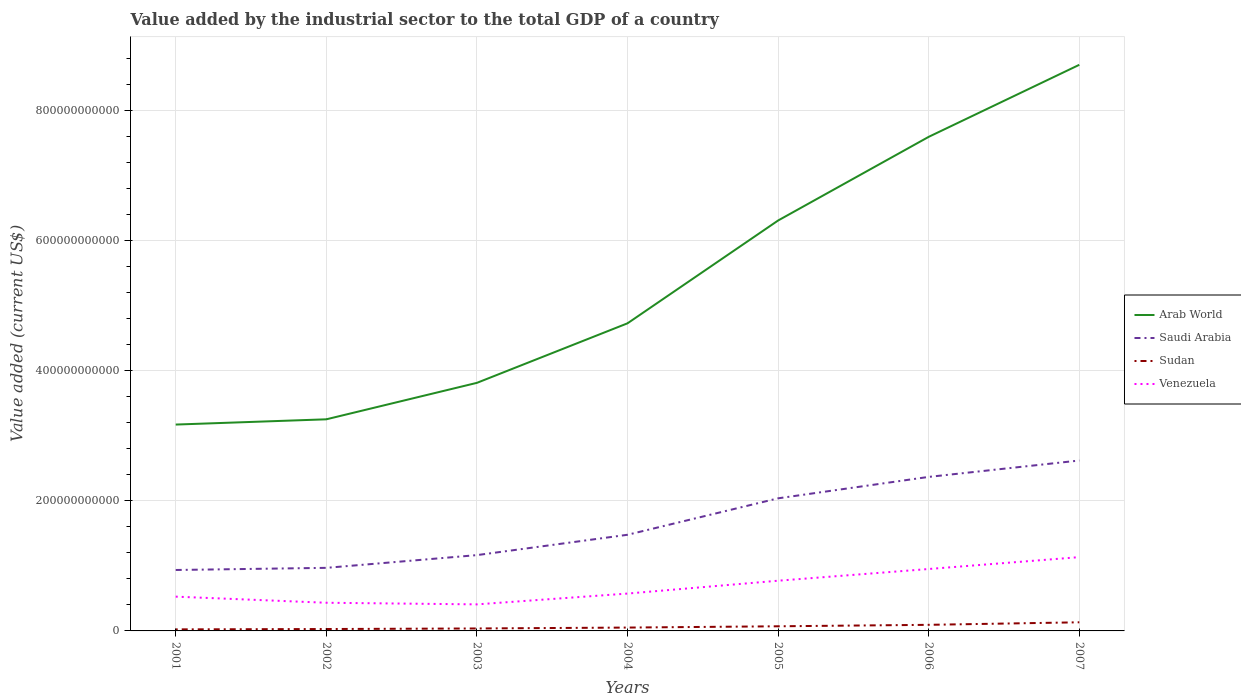How many different coloured lines are there?
Your answer should be compact. 4. Does the line corresponding to Saudi Arabia intersect with the line corresponding to Arab World?
Give a very brief answer. No. Across all years, what is the maximum value added by the industrial sector to the total GDP in Saudi Arabia?
Offer a very short reply. 9.38e+1. What is the total value added by the industrial sector to the total GDP in Sudan in the graph?
Offer a very short reply. -4.22e+09. What is the difference between the highest and the second highest value added by the industrial sector to the total GDP in Saudi Arabia?
Make the answer very short. 1.68e+11. Is the value added by the industrial sector to the total GDP in Saudi Arabia strictly greater than the value added by the industrial sector to the total GDP in Arab World over the years?
Your answer should be very brief. Yes. What is the difference between two consecutive major ticks on the Y-axis?
Make the answer very short. 2.00e+11. Are the values on the major ticks of Y-axis written in scientific E-notation?
Make the answer very short. No. Does the graph contain grids?
Offer a very short reply. Yes. Where does the legend appear in the graph?
Your answer should be very brief. Center right. How many legend labels are there?
Give a very brief answer. 4. What is the title of the graph?
Offer a very short reply. Value added by the industrial sector to the total GDP of a country. Does "Sweden" appear as one of the legend labels in the graph?
Offer a very short reply. No. What is the label or title of the Y-axis?
Your response must be concise. Value added (current US$). What is the Value added (current US$) of Arab World in 2001?
Your response must be concise. 3.18e+11. What is the Value added (current US$) in Saudi Arabia in 2001?
Make the answer very short. 9.38e+1. What is the Value added (current US$) in Sudan in 2001?
Offer a very short reply. 2.37e+09. What is the Value added (current US$) in Venezuela in 2001?
Offer a very short reply. 5.27e+1. What is the Value added (current US$) in Arab World in 2002?
Your answer should be compact. 3.26e+11. What is the Value added (current US$) in Saudi Arabia in 2002?
Keep it short and to the point. 9.71e+1. What is the Value added (current US$) of Sudan in 2002?
Offer a very short reply. 2.92e+09. What is the Value added (current US$) of Venezuela in 2002?
Your answer should be very brief. 4.33e+1. What is the Value added (current US$) in Arab World in 2003?
Make the answer very short. 3.82e+11. What is the Value added (current US$) of Saudi Arabia in 2003?
Make the answer very short. 1.17e+11. What is the Value added (current US$) in Sudan in 2003?
Your answer should be very brief. 3.78e+09. What is the Value added (current US$) of Venezuela in 2003?
Your answer should be compact. 4.08e+1. What is the Value added (current US$) of Arab World in 2004?
Ensure brevity in your answer.  4.73e+11. What is the Value added (current US$) of Saudi Arabia in 2004?
Your answer should be very brief. 1.48e+11. What is the Value added (current US$) in Sudan in 2004?
Give a very brief answer. 5.16e+09. What is the Value added (current US$) of Venezuela in 2004?
Offer a very short reply. 5.75e+1. What is the Value added (current US$) of Arab World in 2005?
Your response must be concise. 6.31e+11. What is the Value added (current US$) of Saudi Arabia in 2005?
Provide a short and direct response. 2.04e+11. What is the Value added (current US$) of Sudan in 2005?
Your answer should be very brief. 7.13e+09. What is the Value added (current US$) in Venezuela in 2005?
Your answer should be compact. 7.73e+1. What is the Value added (current US$) of Arab World in 2006?
Offer a very short reply. 7.60e+11. What is the Value added (current US$) in Saudi Arabia in 2006?
Provide a succinct answer. 2.37e+11. What is the Value added (current US$) of Sudan in 2006?
Provide a short and direct response. 9.38e+09. What is the Value added (current US$) of Venezuela in 2006?
Ensure brevity in your answer.  9.53e+1. What is the Value added (current US$) of Arab World in 2007?
Make the answer very short. 8.71e+11. What is the Value added (current US$) of Saudi Arabia in 2007?
Provide a short and direct response. 2.62e+11. What is the Value added (current US$) in Sudan in 2007?
Keep it short and to the point. 1.33e+1. What is the Value added (current US$) in Venezuela in 2007?
Keep it short and to the point. 1.14e+11. Across all years, what is the maximum Value added (current US$) in Arab World?
Offer a terse response. 8.71e+11. Across all years, what is the maximum Value added (current US$) of Saudi Arabia?
Your response must be concise. 2.62e+11. Across all years, what is the maximum Value added (current US$) in Sudan?
Your answer should be very brief. 1.33e+1. Across all years, what is the maximum Value added (current US$) of Venezuela?
Ensure brevity in your answer.  1.14e+11. Across all years, what is the minimum Value added (current US$) of Arab World?
Offer a terse response. 3.18e+11. Across all years, what is the minimum Value added (current US$) in Saudi Arabia?
Your answer should be compact. 9.38e+1. Across all years, what is the minimum Value added (current US$) in Sudan?
Your response must be concise. 2.37e+09. Across all years, what is the minimum Value added (current US$) of Venezuela?
Keep it short and to the point. 4.08e+1. What is the total Value added (current US$) of Arab World in the graph?
Your response must be concise. 3.76e+12. What is the total Value added (current US$) in Saudi Arabia in the graph?
Provide a short and direct response. 1.16e+12. What is the total Value added (current US$) of Sudan in the graph?
Provide a succinct answer. 4.40e+1. What is the total Value added (current US$) in Venezuela in the graph?
Your response must be concise. 4.80e+11. What is the difference between the Value added (current US$) in Arab World in 2001 and that in 2002?
Provide a succinct answer. -8.06e+09. What is the difference between the Value added (current US$) in Saudi Arabia in 2001 and that in 2002?
Provide a short and direct response. -3.30e+09. What is the difference between the Value added (current US$) of Sudan in 2001 and that in 2002?
Your answer should be very brief. -5.44e+08. What is the difference between the Value added (current US$) in Venezuela in 2001 and that in 2002?
Your response must be concise. 9.40e+09. What is the difference between the Value added (current US$) in Arab World in 2001 and that in 2003?
Make the answer very short. -6.42e+1. What is the difference between the Value added (current US$) of Saudi Arabia in 2001 and that in 2003?
Provide a succinct answer. -2.29e+1. What is the difference between the Value added (current US$) in Sudan in 2001 and that in 2003?
Provide a succinct answer. -1.40e+09. What is the difference between the Value added (current US$) of Venezuela in 2001 and that in 2003?
Your response must be concise. 1.19e+1. What is the difference between the Value added (current US$) of Arab World in 2001 and that in 2004?
Provide a succinct answer. -1.56e+11. What is the difference between the Value added (current US$) in Saudi Arabia in 2001 and that in 2004?
Your response must be concise. -5.42e+1. What is the difference between the Value added (current US$) of Sudan in 2001 and that in 2004?
Offer a very short reply. -2.79e+09. What is the difference between the Value added (current US$) of Venezuela in 2001 and that in 2004?
Keep it short and to the point. -4.74e+09. What is the difference between the Value added (current US$) in Arab World in 2001 and that in 2005?
Your answer should be compact. -3.14e+11. What is the difference between the Value added (current US$) of Saudi Arabia in 2001 and that in 2005?
Keep it short and to the point. -1.10e+11. What is the difference between the Value added (current US$) in Sudan in 2001 and that in 2005?
Offer a very short reply. -4.75e+09. What is the difference between the Value added (current US$) in Venezuela in 2001 and that in 2005?
Your response must be concise. -2.45e+1. What is the difference between the Value added (current US$) in Arab World in 2001 and that in 2006?
Your response must be concise. -4.43e+11. What is the difference between the Value added (current US$) of Saudi Arabia in 2001 and that in 2006?
Ensure brevity in your answer.  -1.43e+11. What is the difference between the Value added (current US$) of Sudan in 2001 and that in 2006?
Your response must be concise. -7.01e+09. What is the difference between the Value added (current US$) of Venezuela in 2001 and that in 2006?
Your answer should be very brief. -4.25e+1. What is the difference between the Value added (current US$) in Arab World in 2001 and that in 2007?
Provide a succinct answer. -5.54e+11. What is the difference between the Value added (current US$) of Saudi Arabia in 2001 and that in 2007?
Make the answer very short. -1.68e+11. What is the difference between the Value added (current US$) of Sudan in 2001 and that in 2007?
Provide a short and direct response. -1.09e+1. What is the difference between the Value added (current US$) of Venezuela in 2001 and that in 2007?
Provide a succinct answer. -6.08e+1. What is the difference between the Value added (current US$) in Arab World in 2002 and that in 2003?
Ensure brevity in your answer.  -5.61e+1. What is the difference between the Value added (current US$) in Saudi Arabia in 2002 and that in 2003?
Your response must be concise. -1.96e+1. What is the difference between the Value added (current US$) in Sudan in 2002 and that in 2003?
Your answer should be very brief. -8.58e+08. What is the difference between the Value added (current US$) of Venezuela in 2002 and that in 2003?
Provide a succinct answer. 2.50e+09. What is the difference between the Value added (current US$) in Arab World in 2002 and that in 2004?
Provide a short and direct response. -1.48e+11. What is the difference between the Value added (current US$) of Saudi Arabia in 2002 and that in 2004?
Your answer should be compact. -5.09e+1. What is the difference between the Value added (current US$) of Sudan in 2002 and that in 2004?
Keep it short and to the point. -2.24e+09. What is the difference between the Value added (current US$) in Venezuela in 2002 and that in 2004?
Provide a succinct answer. -1.41e+1. What is the difference between the Value added (current US$) in Arab World in 2002 and that in 2005?
Ensure brevity in your answer.  -3.06e+11. What is the difference between the Value added (current US$) in Saudi Arabia in 2002 and that in 2005?
Ensure brevity in your answer.  -1.07e+11. What is the difference between the Value added (current US$) of Sudan in 2002 and that in 2005?
Give a very brief answer. -4.21e+09. What is the difference between the Value added (current US$) in Venezuela in 2002 and that in 2005?
Make the answer very short. -3.39e+1. What is the difference between the Value added (current US$) of Arab World in 2002 and that in 2006?
Your response must be concise. -4.35e+11. What is the difference between the Value added (current US$) of Saudi Arabia in 2002 and that in 2006?
Ensure brevity in your answer.  -1.40e+11. What is the difference between the Value added (current US$) of Sudan in 2002 and that in 2006?
Ensure brevity in your answer.  -6.46e+09. What is the difference between the Value added (current US$) of Venezuela in 2002 and that in 2006?
Keep it short and to the point. -5.19e+1. What is the difference between the Value added (current US$) of Arab World in 2002 and that in 2007?
Your response must be concise. -5.45e+11. What is the difference between the Value added (current US$) in Saudi Arabia in 2002 and that in 2007?
Offer a terse response. -1.65e+11. What is the difference between the Value added (current US$) of Sudan in 2002 and that in 2007?
Provide a short and direct response. -1.03e+1. What is the difference between the Value added (current US$) in Venezuela in 2002 and that in 2007?
Your answer should be compact. -7.02e+1. What is the difference between the Value added (current US$) of Arab World in 2003 and that in 2004?
Offer a very short reply. -9.16e+1. What is the difference between the Value added (current US$) of Saudi Arabia in 2003 and that in 2004?
Make the answer very short. -3.13e+1. What is the difference between the Value added (current US$) of Sudan in 2003 and that in 2004?
Your response must be concise. -1.38e+09. What is the difference between the Value added (current US$) of Venezuela in 2003 and that in 2004?
Your answer should be compact. -1.66e+1. What is the difference between the Value added (current US$) of Arab World in 2003 and that in 2005?
Your answer should be very brief. -2.50e+11. What is the difference between the Value added (current US$) in Saudi Arabia in 2003 and that in 2005?
Your response must be concise. -8.74e+1. What is the difference between the Value added (current US$) of Sudan in 2003 and that in 2005?
Offer a very short reply. -3.35e+09. What is the difference between the Value added (current US$) of Venezuela in 2003 and that in 2005?
Ensure brevity in your answer.  -3.64e+1. What is the difference between the Value added (current US$) of Arab World in 2003 and that in 2006?
Offer a terse response. -3.79e+11. What is the difference between the Value added (current US$) of Saudi Arabia in 2003 and that in 2006?
Ensure brevity in your answer.  -1.20e+11. What is the difference between the Value added (current US$) in Sudan in 2003 and that in 2006?
Make the answer very short. -5.61e+09. What is the difference between the Value added (current US$) in Venezuela in 2003 and that in 2006?
Your answer should be compact. -5.44e+1. What is the difference between the Value added (current US$) of Arab World in 2003 and that in 2007?
Your answer should be very brief. -4.89e+11. What is the difference between the Value added (current US$) in Saudi Arabia in 2003 and that in 2007?
Your answer should be compact. -1.46e+11. What is the difference between the Value added (current US$) in Sudan in 2003 and that in 2007?
Keep it short and to the point. -9.49e+09. What is the difference between the Value added (current US$) in Venezuela in 2003 and that in 2007?
Provide a short and direct response. -7.27e+1. What is the difference between the Value added (current US$) of Arab World in 2004 and that in 2005?
Your answer should be compact. -1.58e+11. What is the difference between the Value added (current US$) in Saudi Arabia in 2004 and that in 2005?
Offer a very short reply. -5.61e+1. What is the difference between the Value added (current US$) in Sudan in 2004 and that in 2005?
Provide a short and direct response. -1.97e+09. What is the difference between the Value added (current US$) of Venezuela in 2004 and that in 2005?
Your answer should be very brief. -1.98e+1. What is the difference between the Value added (current US$) in Arab World in 2004 and that in 2006?
Make the answer very short. -2.87e+11. What is the difference between the Value added (current US$) in Saudi Arabia in 2004 and that in 2006?
Your answer should be very brief. -8.90e+1. What is the difference between the Value added (current US$) of Sudan in 2004 and that in 2006?
Your answer should be very brief. -4.22e+09. What is the difference between the Value added (current US$) of Venezuela in 2004 and that in 2006?
Keep it short and to the point. -3.78e+1. What is the difference between the Value added (current US$) in Arab World in 2004 and that in 2007?
Offer a very short reply. -3.98e+11. What is the difference between the Value added (current US$) in Saudi Arabia in 2004 and that in 2007?
Make the answer very short. -1.14e+11. What is the difference between the Value added (current US$) of Sudan in 2004 and that in 2007?
Your answer should be compact. -8.10e+09. What is the difference between the Value added (current US$) in Venezuela in 2004 and that in 2007?
Provide a short and direct response. -5.61e+1. What is the difference between the Value added (current US$) in Arab World in 2005 and that in 2006?
Give a very brief answer. -1.29e+11. What is the difference between the Value added (current US$) of Saudi Arabia in 2005 and that in 2006?
Offer a terse response. -3.30e+1. What is the difference between the Value added (current US$) of Sudan in 2005 and that in 2006?
Your answer should be very brief. -2.25e+09. What is the difference between the Value added (current US$) of Venezuela in 2005 and that in 2006?
Offer a terse response. -1.80e+1. What is the difference between the Value added (current US$) of Arab World in 2005 and that in 2007?
Your response must be concise. -2.40e+11. What is the difference between the Value added (current US$) of Saudi Arabia in 2005 and that in 2007?
Ensure brevity in your answer.  -5.82e+1. What is the difference between the Value added (current US$) in Sudan in 2005 and that in 2007?
Give a very brief answer. -6.13e+09. What is the difference between the Value added (current US$) of Venezuela in 2005 and that in 2007?
Your answer should be very brief. -3.63e+1. What is the difference between the Value added (current US$) in Arab World in 2006 and that in 2007?
Offer a terse response. -1.11e+11. What is the difference between the Value added (current US$) in Saudi Arabia in 2006 and that in 2007?
Your answer should be compact. -2.52e+1. What is the difference between the Value added (current US$) in Sudan in 2006 and that in 2007?
Offer a very short reply. -3.88e+09. What is the difference between the Value added (current US$) of Venezuela in 2006 and that in 2007?
Provide a succinct answer. -1.83e+1. What is the difference between the Value added (current US$) of Arab World in 2001 and the Value added (current US$) of Saudi Arabia in 2002?
Give a very brief answer. 2.20e+11. What is the difference between the Value added (current US$) in Arab World in 2001 and the Value added (current US$) in Sudan in 2002?
Keep it short and to the point. 3.15e+11. What is the difference between the Value added (current US$) in Arab World in 2001 and the Value added (current US$) in Venezuela in 2002?
Ensure brevity in your answer.  2.74e+11. What is the difference between the Value added (current US$) in Saudi Arabia in 2001 and the Value added (current US$) in Sudan in 2002?
Your response must be concise. 9.08e+1. What is the difference between the Value added (current US$) in Saudi Arabia in 2001 and the Value added (current US$) in Venezuela in 2002?
Keep it short and to the point. 5.04e+1. What is the difference between the Value added (current US$) in Sudan in 2001 and the Value added (current US$) in Venezuela in 2002?
Your answer should be compact. -4.10e+1. What is the difference between the Value added (current US$) in Arab World in 2001 and the Value added (current US$) in Saudi Arabia in 2003?
Make the answer very short. 2.01e+11. What is the difference between the Value added (current US$) of Arab World in 2001 and the Value added (current US$) of Sudan in 2003?
Your answer should be very brief. 3.14e+11. What is the difference between the Value added (current US$) in Arab World in 2001 and the Value added (current US$) in Venezuela in 2003?
Provide a succinct answer. 2.77e+11. What is the difference between the Value added (current US$) in Saudi Arabia in 2001 and the Value added (current US$) in Sudan in 2003?
Provide a succinct answer. 9.00e+1. What is the difference between the Value added (current US$) in Saudi Arabia in 2001 and the Value added (current US$) in Venezuela in 2003?
Your response must be concise. 5.29e+1. What is the difference between the Value added (current US$) of Sudan in 2001 and the Value added (current US$) of Venezuela in 2003?
Ensure brevity in your answer.  -3.85e+1. What is the difference between the Value added (current US$) in Arab World in 2001 and the Value added (current US$) in Saudi Arabia in 2004?
Your answer should be very brief. 1.70e+11. What is the difference between the Value added (current US$) of Arab World in 2001 and the Value added (current US$) of Sudan in 2004?
Provide a short and direct response. 3.12e+11. What is the difference between the Value added (current US$) of Arab World in 2001 and the Value added (current US$) of Venezuela in 2004?
Offer a very short reply. 2.60e+11. What is the difference between the Value added (current US$) of Saudi Arabia in 2001 and the Value added (current US$) of Sudan in 2004?
Your answer should be compact. 8.86e+1. What is the difference between the Value added (current US$) in Saudi Arabia in 2001 and the Value added (current US$) in Venezuela in 2004?
Keep it short and to the point. 3.63e+1. What is the difference between the Value added (current US$) of Sudan in 2001 and the Value added (current US$) of Venezuela in 2004?
Your answer should be compact. -5.51e+1. What is the difference between the Value added (current US$) of Arab World in 2001 and the Value added (current US$) of Saudi Arabia in 2005?
Provide a short and direct response. 1.14e+11. What is the difference between the Value added (current US$) in Arab World in 2001 and the Value added (current US$) in Sudan in 2005?
Provide a succinct answer. 3.10e+11. What is the difference between the Value added (current US$) in Arab World in 2001 and the Value added (current US$) in Venezuela in 2005?
Give a very brief answer. 2.40e+11. What is the difference between the Value added (current US$) in Saudi Arabia in 2001 and the Value added (current US$) in Sudan in 2005?
Your answer should be very brief. 8.66e+1. What is the difference between the Value added (current US$) of Saudi Arabia in 2001 and the Value added (current US$) of Venezuela in 2005?
Provide a short and direct response. 1.65e+1. What is the difference between the Value added (current US$) in Sudan in 2001 and the Value added (current US$) in Venezuela in 2005?
Keep it short and to the point. -7.49e+1. What is the difference between the Value added (current US$) of Arab World in 2001 and the Value added (current US$) of Saudi Arabia in 2006?
Ensure brevity in your answer.  8.05e+1. What is the difference between the Value added (current US$) in Arab World in 2001 and the Value added (current US$) in Sudan in 2006?
Ensure brevity in your answer.  3.08e+11. What is the difference between the Value added (current US$) of Arab World in 2001 and the Value added (current US$) of Venezuela in 2006?
Provide a short and direct response. 2.22e+11. What is the difference between the Value added (current US$) in Saudi Arabia in 2001 and the Value added (current US$) in Sudan in 2006?
Provide a short and direct response. 8.44e+1. What is the difference between the Value added (current US$) of Saudi Arabia in 2001 and the Value added (current US$) of Venezuela in 2006?
Provide a short and direct response. -1.52e+09. What is the difference between the Value added (current US$) in Sudan in 2001 and the Value added (current US$) in Venezuela in 2006?
Give a very brief answer. -9.29e+1. What is the difference between the Value added (current US$) of Arab World in 2001 and the Value added (current US$) of Saudi Arabia in 2007?
Your answer should be compact. 5.53e+1. What is the difference between the Value added (current US$) of Arab World in 2001 and the Value added (current US$) of Sudan in 2007?
Provide a succinct answer. 3.04e+11. What is the difference between the Value added (current US$) in Arab World in 2001 and the Value added (current US$) in Venezuela in 2007?
Provide a succinct answer. 2.04e+11. What is the difference between the Value added (current US$) in Saudi Arabia in 2001 and the Value added (current US$) in Sudan in 2007?
Keep it short and to the point. 8.05e+1. What is the difference between the Value added (current US$) of Saudi Arabia in 2001 and the Value added (current US$) of Venezuela in 2007?
Offer a terse response. -1.98e+1. What is the difference between the Value added (current US$) of Sudan in 2001 and the Value added (current US$) of Venezuela in 2007?
Your response must be concise. -1.11e+11. What is the difference between the Value added (current US$) of Arab World in 2002 and the Value added (current US$) of Saudi Arabia in 2003?
Your answer should be very brief. 2.09e+11. What is the difference between the Value added (current US$) in Arab World in 2002 and the Value added (current US$) in Sudan in 2003?
Your response must be concise. 3.22e+11. What is the difference between the Value added (current US$) in Arab World in 2002 and the Value added (current US$) in Venezuela in 2003?
Offer a terse response. 2.85e+11. What is the difference between the Value added (current US$) of Saudi Arabia in 2002 and the Value added (current US$) of Sudan in 2003?
Keep it short and to the point. 9.33e+1. What is the difference between the Value added (current US$) of Saudi Arabia in 2002 and the Value added (current US$) of Venezuela in 2003?
Offer a very short reply. 5.62e+1. What is the difference between the Value added (current US$) of Sudan in 2002 and the Value added (current US$) of Venezuela in 2003?
Keep it short and to the point. -3.79e+1. What is the difference between the Value added (current US$) in Arab World in 2002 and the Value added (current US$) in Saudi Arabia in 2004?
Your answer should be compact. 1.78e+11. What is the difference between the Value added (current US$) in Arab World in 2002 and the Value added (current US$) in Sudan in 2004?
Your answer should be compact. 3.20e+11. What is the difference between the Value added (current US$) in Arab World in 2002 and the Value added (current US$) in Venezuela in 2004?
Your response must be concise. 2.68e+11. What is the difference between the Value added (current US$) in Saudi Arabia in 2002 and the Value added (current US$) in Sudan in 2004?
Offer a very short reply. 9.19e+1. What is the difference between the Value added (current US$) in Saudi Arabia in 2002 and the Value added (current US$) in Venezuela in 2004?
Provide a succinct answer. 3.96e+1. What is the difference between the Value added (current US$) in Sudan in 2002 and the Value added (current US$) in Venezuela in 2004?
Ensure brevity in your answer.  -5.46e+1. What is the difference between the Value added (current US$) in Arab World in 2002 and the Value added (current US$) in Saudi Arabia in 2005?
Keep it short and to the point. 1.22e+11. What is the difference between the Value added (current US$) of Arab World in 2002 and the Value added (current US$) of Sudan in 2005?
Your response must be concise. 3.18e+11. What is the difference between the Value added (current US$) of Arab World in 2002 and the Value added (current US$) of Venezuela in 2005?
Provide a succinct answer. 2.48e+11. What is the difference between the Value added (current US$) in Saudi Arabia in 2002 and the Value added (current US$) in Sudan in 2005?
Offer a terse response. 8.99e+1. What is the difference between the Value added (current US$) in Saudi Arabia in 2002 and the Value added (current US$) in Venezuela in 2005?
Your answer should be compact. 1.98e+1. What is the difference between the Value added (current US$) of Sudan in 2002 and the Value added (current US$) of Venezuela in 2005?
Your answer should be compact. -7.43e+1. What is the difference between the Value added (current US$) in Arab World in 2002 and the Value added (current US$) in Saudi Arabia in 2006?
Make the answer very short. 8.86e+1. What is the difference between the Value added (current US$) in Arab World in 2002 and the Value added (current US$) in Sudan in 2006?
Give a very brief answer. 3.16e+11. What is the difference between the Value added (current US$) in Arab World in 2002 and the Value added (current US$) in Venezuela in 2006?
Offer a terse response. 2.30e+11. What is the difference between the Value added (current US$) of Saudi Arabia in 2002 and the Value added (current US$) of Sudan in 2006?
Ensure brevity in your answer.  8.77e+1. What is the difference between the Value added (current US$) of Saudi Arabia in 2002 and the Value added (current US$) of Venezuela in 2006?
Give a very brief answer. 1.78e+09. What is the difference between the Value added (current US$) of Sudan in 2002 and the Value added (current US$) of Venezuela in 2006?
Your response must be concise. -9.24e+1. What is the difference between the Value added (current US$) in Arab World in 2002 and the Value added (current US$) in Saudi Arabia in 2007?
Your response must be concise. 6.34e+1. What is the difference between the Value added (current US$) in Arab World in 2002 and the Value added (current US$) in Sudan in 2007?
Ensure brevity in your answer.  3.12e+11. What is the difference between the Value added (current US$) of Arab World in 2002 and the Value added (current US$) of Venezuela in 2007?
Keep it short and to the point. 2.12e+11. What is the difference between the Value added (current US$) of Saudi Arabia in 2002 and the Value added (current US$) of Sudan in 2007?
Offer a very short reply. 8.38e+1. What is the difference between the Value added (current US$) in Saudi Arabia in 2002 and the Value added (current US$) in Venezuela in 2007?
Provide a short and direct response. -1.65e+1. What is the difference between the Value added (current US$) of Sudan in 2002 and the Value added (current US$) of Venezuela in 2007?
Offer a terse response. -1.11e+11. What is the difference between the Value added (current US$) of Arab World in 2003 and the Value added (current US$) of Saudi Arabia in 2004?
Provide a succinct answer. 2.34e+11. What is the difference between the Value added (current US$) in Arab World in 2003 and the Value added (current US$) in Sudan in 2004?
Give a very brief answer. 3.77e+11. What is the difference between the Value added (current US$) of Arab World in 2003 and the Value added (current US$) of Venezuela in 2004?
Provide a short and direct response. 3.24e+11. What is the difference between the Value added (current US$) of Saudi Arabia in 2003 and the Value added (current US$) of Sudan in 2004?
Ensure brevity in your answer.  1.11e+11. What is the difference between the Value added (current US$) of Saudi Arabia in 2003 and the Value added (current US$) of Venezuela in 2004?
Provide a succinct answer. 5.92e+1. What is the difference between the Value added (current US$) in Sudan in 2003 and the Value added (current US$) in Venezuela in 2004?
Your answer should be compact. -5.37e+1. What is the difference between the Value added (current US$) of Arab World in 2003 and the Value added (current US$) of Saudi Arabia in 2005?
Offer a very short reply. 1.78e+11. What is the difference between the Value added (current US$) of Arab World in 2003 and the Value added (current US$) of Sudan in 2005?
Your response must be concise. 3.75e+11. What is the difference between the Value added (current US$) in Arab World in 2003 and the Value added (current US$) in Venezuela in 2005?
Provide a short and direct response. 3.04e+11. What is the difference between the Value added (current US$) of Saudi Arabia in 2003 and the Value added (current US$) of Sudan in 2005?
Make the answer very short. 1.10e+11. What is the difference between the Value added (current US$) in Saudi Arabia in 2003 and the Value added (current US$) in Venezuela in 2005?
Your answer should be compact. 3.94e+1. What is the difference between the Value added (current US$) in Sudan in 2003 and the Value added (current US$) in Venezuela in 2005?
Your answer should be compact. -7.35e+1. What is the difference between the Value added (current US$) of Arab World in 2003 and the Value added (current US$) of Saudi Arabia in 2006?
Your response must be concise. 1.45e+11. What is the difference between the Value added (current US$) of Arab World in 2003 and the Value added (current US$) of Sudan in 2006?
Your answer should be compact. 3.72e+11. What is the difference between the Value added (current US$) of Arab World in 2003 and the Value added (current US$) of Venezuela in 2006?
Provide a succinct answer. 2.86e+11. What is the difference between the Value added (current US$) of Saudi Arabia in 2003 and the Value added (current US$) of Sudan in 2006?
Offer a terse response. 1.07e+11. What is the difference between the Value added (current US$) in Saudi Arabia in 2003 and the Value added (current US$) in Venezuela in 2006?
Your answer should be very brief. 2.14e+1. What is the difference between the Value added (current US$) of Sudan in 2003 and the Value added (current US$) of Venezuela in 2006?
Your answer should be very brief. -9.15e+1. What is the difference between the Value added (current US$) of Arab World in 2003 and the Value added (current US$) of Saudi Arabia in 2007?
Make the answer very short. 1.19e+11. What is the difference between the Value added (current US$) of Arab World in 2003 and the Value added (current US$) of Sudan in 2007?
Your response must be concise. 3.68e+11. What is the difference between the Value added (current US$) in Arab World in 2003 and the Value added (current US$) in Venezuela in 2007?
Offer a terse response. 2.68e+11. What is the difference between the Value added (current US$) in Saudi Arabia in 2003 and the Value added (current US$) in Sudan in 2007?
Provide a short and direct response. 1.03e+11. What is the difference between the Value added (current US$) of Saudi Arabia in 2003 and the Value added (current US$) of Venezuela in 2007?
Your response must be concise. 3.11e+09. What is the difference between the Value added (current US$) of Sudan in 2003 and the Value added (current US$) of Venezuela in 2007?
Your response must be concise. -1.10e+11. What is the difference between the Value added (current US$) of Arab World in 2004 and the Value added (current US$) of Saudi Arabia in 2005?
Your answer should be compact. 2.69e+11. What is the difference between the Value added (current US$) of Arab World in 2004 and the Value added (current US$) of Sudan in 2005?
Your answer should be compact. 4.66e+11. What is the difference between the Value added (current US$) in Arab World in 2004 and the Value added (current US$) in Venezuela in 2005?
Give a very brief answer. 3.96e+11. What is the difference between the Value added (current US$) of Saudi Arabia in 2004 and the Value added (current US$) of Sudan in 2005?
Your answer should be compact. 1.41e+11. What is the difference between the Value added (current US$) in Saudi Arabia in 2004 and the Value added (current US$) in Venezuela in 2005?
Your answer should be very brief. 7.07e+1. What is the difference between the Value added (current US$) of Sudan in 2004 and the Value added (current US$) of Venezuela in 2005?
Give a very brief answer. -7.21e+1. What is the difference between the Value added (current US$) of Arab World in 2004 and the Value added (current US$) of Saudi Arabia in 2006?
Give a very brief answer. 2.36e+11. What is the difference between the Value added (current US$) of Arab World in 2004 and the Value added (current US$) of Sudan in 2006?
Provide a short and direct response. 4.64e+11. What is the difference between the Value added (current US$) of Arab World in 2004 and the Value added (current US$) of Venezuela in 2006?
Give a very brief answer. 3.78e+11. What is the difference between the Value added (current US$) in Saudi Arabia in 2004 and the Value added (current US$) in Sudan in 2006?
Your answer should be very brief. 1.39e+11. What is the difference between the Value added (current US$) of Saudi Arabia in 2004 and the Value added (current US$) of Venezuela in 2006?
Your response must be concise. 5.27e+1. What is the difference between the Value added (current US$) in Sudan in 2004 and the Value added (current US$) in Venezuela in 2006?
Give a very brief answer. -9.01e+1. What is the difference between the Value added (current US$) of Arab World in 2004 and the Value added (current US$) of Saudi Arabia in 2007?
Your response must be concise. 2.11e+11. What is the difference between the Value added (current US$) in Arab World in 2004 and the Value added (current US$) in Sudan in 2007?
Your answer should be very brief. 4.60e+11. What is the difference between the Value added (current US$) of Arab World in 2004 and the Value added (current US$) of Venezuela in 2007?
Your answer should be very brief. 3.60e+11. What is the difference between the Value added (current US$) in Saudi Arabia in 2004 and the Value added (current US$) in Sudan in 2007?
Keep it short and to the point. 1.35e+11. What is the difference between the Value added (current US$) in Saudi Arabia in 2004 and the Value added (current US$) in Venezuela in 2007?
Offer a very short reply. 3.44e+1. What is the difference between the Value added (current US$) in Sudan in 2004 and the Value added (current US$) in Venezuela in 2007?
Give a very brief answer. -1.08e+11. What is the difference between the Value added (current US$) in Arab World in 2005 and the Value added (current US$) in Saudi Arabia in 2006?
Provide a succinct answer. 3.95e+11. What is the difference between the Value added (current US$) in Arab World in 2005 and the Value added (current US$) in Sudan in 2006?
Offer a terse response. 6.22e+11. What is the difference between the Value added (current US$) of Arab World in 2005 and the Value added (current US$) of Venezuela in 2006?
Your response must be concise. 5.36e+11. What is the difference between the Value added (current US$) of Saudi Arabia in 2005 and the Value added (current US$) of Sudan in 2006?
Your answer should be compact. 1.95e+11. What is the difference between the Value added (current US$) in Saudi Arabia in 2005 and the Value added (current US$) in Venezuela in 2006?
Your answer should be compact. 1.09e+11. What is the difference between the Value added (current US$) in Sudan in 2005 and the Value added (current US$) in Venezuela in 2006?
Make the answer very short. -8.81e+1. What is the difference between the Value added (current US$) of Arab World in 2005 and the Value added (current US$) of Saudi Arabia in 2007?
Your answer should be very brief. 3.69e+11. What is the difference between the Value added (current US$) in Arab World in 2005 and the Value added (current US$) in Sudan in 2007?
Keep it short and to the point. 6.18e+11. What is the difference between the Value added (current US$) in Arab World in 2005 and the Value added (current US$) in Venezuela in 2007?
Provide a succinct answer. 5.18e+11. What is the difference between the Value added (current US$) in Saudi Arabia in 2005 and the Value added (current US$) in Sudan in 2007?
Provide a short and direct response. 1.91e+11. What is the difference between the Value added (current US$) of Saudi Arabia in 2005 and the Value added (current US$) of Venezuela in 2007?
Provide a succinct answer. 9.05e+1. What is the difference between the Value added (current US$) in Sudan in 2005 and the Value added (current US$) in Venezuela in 2007?
Ensure brevity in your answer.  -1.06e+11. What is the difference between the Value added (current US$) in Arab World in 2006 and the Value added (current US$) in Saudi Arabia in 2007?
Keep it short and to the point. 4.98e+11. What is the difference between the Value added (current US$) in Arab World in 2006 and the Value added (current US$) in Sudan in 2007?
Offer a very short reply. 7.47e+11. What is the difference between the Value added (current US$) of Arab World in 2006 and the Value added (current US$) of Venezuela in 2007?
Give a very brief answer. 6.47e+11. What is the difference between the Value added (current US$) in Saudi Arabia in 2006 and the Value added (current US$) in Sudan in 2007?
Offer a terse response. 2.24e+11. What is the difference between the Value added (current US$) in Saudi Arabia in 2006 and the Value added (current US$) in Venezuela in 2007?
Your answer should be very brief. 1.23e+11. What is the difference between the Value added (current US$) of Sudan in 2006 and the Value added (current US$) of Venezuela in 2007?
Your response must be concise. -1.04e+11. What is the average Value added (current US$) in Arab World per year?
Keep it short and to the point. 5.37e+11. What is the average Value added (current US$) in Saudi Arabia per year?
Offer a terse response. 1.66e+11. What is the average Value added (current US$) in Sudan per year?
Provide a short and direct response. 6.29e+09. What is the average Value added (current US$) in Venezuela per year?
Give a very brief answer. 6.86e+1. In the year 2001, what is the difference between the Value added (current US$) in Arab World and Value added (current US$) in Saudi Arabia?
Your answer should be very brief. 2.24e+11. In the year 2001, what is the difference between the Value added (current US$) of Arab World and Value added (current US$) of Sudan?
Offer a very short reply. 3.15e+11. In the year 2001, what is the difference between the Value added (current US$) in Arab World and Value added (current US$) in Venezuela?
Keep it short and to the point. 2.65e+11. In the year 2001, what is the difference between the Value added (current US$) of Saudi Arabia and Value added (current US$) of Sudan?
Keep it short and to the point. 9.14e+1. In the year 2001, what is the difference between the Value added (current US$) in Saudi Arabia and Value added (current US$) in Venezuela?
Give a very brief answer. 4.10e+1. In the year 2001, what is the difference between the Value added (current US$) of Sudan and Value added (current US$) of Venezuela?
Provide a succinct answer. -5.04e+1. In the year 2002, what is the difference between the Value added (current US$) of Arab World and Value added (current US$) of Saudi Arabia?
Ensure brevity in your answer.  2.29e+11. In the year 2002, what is the difference between the Value added (current US$) in Arab World and Value added (current US$) in Sudan?
Provide a short and direct response. 3.23e+11. In the year 2002, what is the difference between the Value added (current US$) in Arab World and Value added (current US$) in Venezuela?
Offer a very short reply. 2.82e+11. In the year 2002, what is the difference between the Value added (current US$) of Saudi Arabia and Value added (current US$) of Sudan?
Offer a very short reply. 9.41e+1. In the year 2002, what is the difference between the Value added (current US$) of Saudi Arabia and Value added (current US$) of Venezuela?
Make the answer very short. 5.37e+1. In the year 2002, what is the difference between the Value added (current US$) in Sudan and Value added (current US$) in Venezuela?
Your answer should be very brief. -4.04e+1. In the year 2003, what is the difference between the Value added (current US$) in Arab World and Value added (current US$) in Saudi Arabia?
Your response must be concise. 2.65e+11. In the year 2003, what is the difference between the Value added (current US$) in Arab World and Value added (current US$) in Sudan?
Offer a terse response. 3.78e+11. In the year 2003, what is the difference between the Value added (current US$) in Arab World and Value added (current US$) in Venezuela?
Offer a very short reply. 3.41e+11. In the year 2003, what is the difference between the Value added (current US$) of Saudi Arabia and Value added (current US$) of Sudan?
Keep it short and to the point. 1.13e+11. In the year 2003, what is the difference between the Value added (current US$) in Saudi Arabia and Value added (current US$) in Venezuela?
Offer a terse response. 7.58e+1. In the year 2003, what is the difference between the Value added (current US$) of Sudan and Value added (current US$) of Venezuela?
Ensure brevity in your answer.  -3.71e+1. In the year 2004, what is the difference between the Value added (current US$) in Arab World and Value added (current US$) in Saudi Arabia?
Make the answer very short. 3.25e+11. In the year 2004, what is the difference between the Value added (current US$) of Arab World and Value added (current US$) of Sudan?
Your answer should be very brief. 4.68e+11. In the year 2004, what is the difference between the Value added (current US$) of Arab World and Value added (current US$) of Venezuela?
Keep it short and to the point. 4.16e+11. In the year 2004, what is the difference between the Value added (current US$) of Saudi Arabia and Value added (current US$) of Sudan?
Give a very brief answer. 1.43e+11. In the year 2004, what is the difference between the Value added (current US$) of Saudi Arabia and Value added (current US$) of Venezuela?
Your answer should be very brief. 9.05e+1. In the year 2004, what is the difference between the Value added (current US$) of Sudan and Value added (current US$) of Venezuela?
Provide a short and direct response. -5.23e+1. In the year 2005, what is the difference between the Value added (current US$) in Arab World and Value added (current US$) in Saudi Arabia?
Give a very brief answer. 4.27e+11. In the year 2005, what is the difference between the Value added (current US$) in Arab World and Value added (current US$) in Sudan?
Give a very brief answer. 6.24e+11. In the year 2005, what is the difference between the Value added (current US$) in Arab World and Value added (current US$) in Venezuela?
Give a very brief answer. 5.54e+11. In the year 2005, what is the difference between the Value added (current US$) in Saudi Arabia and Value added (current US$) in Sudan?
Give a very brief answer. 1.97e+11. In the year 2005, what is the difference between the Value added (current US$) in Saudi Arabia and Value added (current US$) in Venezuela?
Provide a succinct answer. 1.27e+11. In the year 2005, what is the difference between the Value added (current US$) in Sudan and Value added (current US$) in Venezuela?
Provide a succinct answer. -7.01e+1. In the year 2006, what is the difference between the Value added (current US$) in Arab World and Value added (current US$) in Saudi Arabia?
Make the answer very short. 5.23e+11. In the year 2006, what is the difference between the Value added (current US$) in Arab World and Value added (current US$) in Sudan?
Your response must be concise. 7.51e+11. In the year 2006, what is the difference between the Value added (current US$) in Arab World and Value added (current US$) in Venezuela?
Your response must be concise. 6.65e+11. In the year 2006, what is the difference between the Value added (current US$) in Saudi Arabia and Value added (current US$) in Sudan?
Offer a very short reply. 2.28e+11. In the year 2006, what is the difference between the Value added (current US$) of Saudi Arabia and Value added (current US$) of Venezuela?
Your answer should be compact. 1.42e+11. In the year 2006, what is the difference between the Value added (current US$) of Sudan and Value added (current US$) of Venezuela?
Your answer should be very brief. -8.59e+1. In the year 2007, what is the difference between the Value added (current US$) of Arab World and Value added (current US$) of Saudi Arabia?
Keep it short and to the point. 6.09e+11. In the year 2007, what is the difference between the Value added (current US$) of Arab World and Value added (current US$) of Sudan?
Ensure brevity in your answer.  8.58e+11. In the year 2007, what is the difference between the Value added (current US$) in Arab World and Value added (current US$) in Venezuela?
Ensure brevity in your answer.  7.58e+11. In the year 2007, what is the difference between the Value added (current US$) in Saudi Arabia and Value added (current US$) in Sudan?
Your response must be concise. 2.49e+11. In the year 2007, what is the difference between the Value added (current US$) in Saudi Arabia and Value added (current US$) in Venezuela?
Provide a succinct answer. 1.49e+11. In the year 2007, what is the difference between the Value added (current US$) of Sudan and Value added (current US$) of Venezuela?
Your answer should be compact. -1.00e+11. What is the ratio of the Value added (current US$) in Arab World in 2001 to that in 2002?
Provide a succinct answer. 0.98. What is the ratio of the Value added (current US$) of Sudan in 2001 to that in 2002?
Offer a terse response. 0.81. What is the ratio of the Value added (current US$) of Venezuela in 2001 to that in 2002?
Your answer should be very brief. 1.22. What is the ratio of the Value added (current US$) in Arab World in 2001 to that in 2003?
Your response must be concise. 0.83. What is the ratio of the Value added (current US$) in Saudi Arabia in 2001 to that in 2003?
Ensure brevity in your answer.  0.8. What is the ratio of the Value added (current US$) of Sudan in 2001 to that in 2003?
Your response must be concise. 0.63. What is the ratio of the Value added (current US$) of Venezuela in 2001 to that in 2003?
Offer a very short reply. 1.29. What is the ratio of the Value added (current US$) in Arab World in 2001 to that in 2004?
Provide a short and direct response. 0.67. What is the ratio of the Value added (current US$) of Saudi Arabia in 2001 to that in 2004?
Keep it short and to the point. 0.63. What is the ratio of the Value added (current US$) in Sudan in 2001 to that in 2004?
Your answer should be very brief. 0.46. What is the ratio of the Value added (current US$) in Venezuela in 2001 to that in 2004?
Offer a terse response. 0.92. What is the ratio of the Value added (current US$) of Arab World in 2001 to that in 2005?
Give a very brief answer. 0.5. What is the ratio of the Value added (current US$) of Saudi Arabia in 2001 to that in 2005?
Your answer should be compact. 0.46. What is the ratio of the Value added (current US$) of Sudan in 2001 to that in 2005?
Make the answer very short. 0.33. What is the ratio of the Value added (current US$) in Venezuela in 2001 to that in 2005?
Your answer should be very brief. 0.68. What is the ratio of the Value added (current US$) of Arab World in 2001 to that in 2006?
Make the answer very short. 0.42. What is the ratio of the Value added (current US$) in Saudi Arabia in 2001 to that in 2006?
Your answer should be very brief. 0.4. What is the ratio of the Value added (current US$) of Sudan in 2001 to that in 2006?
Your answer should be compact. 0.25. What is the ratio of the Value added (current US$) in Venezuela in 2001 to that in 2006?
Your answer should be very brief. 0.55. What is the ratio of the Value added (current US$) in Arab World in 2001 to that in 2007?
Ensure brevity in your answer.  0.36. What is the ratio of the Value added (current US$) in Saudi Arabia in 2001 to that in 2007?
Your response must be concise. 0.36. What is the ratio of the Value added (current US$) in Sudan in 2001 to that in 2007?
Make the answer very short. 0.18. What is the ratio of the Value added (current US$) in Venezuela in 2001 to that in 2007?
Ensure brevity in your answer.  0.46. What is the ratio of the Value added (current US$) in Arab World in 2002 to that in 2003?
Make the answer very short. 0.85. What is the ratio of the Value added (current US$) in Saudi Arabia in 2002 to that in 2003?
Offer a very short reply. 0.83. What is the ratio of the Value added (current US$) in Sudan in 2002 to that in 2003?
Your response must be concise. 0.77. What is the ratio of the Value added (current US$) of Venezuela in 2002 to that in 2003?
Provide a short and direct response. 1.06. What is the ratio of the Value added (current US$) of Arab World in 2002 to that in 2004?
Offer a very short reply. 0.69. What is the ratio of the Value added (current US$) of Saudi Arabia in 2002 to that in 2004?
Ensure brevity in your answer.  0.66. What is the ratio of the Value added (current US$) of Sudan in 2002 to that in 2004?
Keep it short and to the point. 0.57. What is the ratio of the Value added (current US$) of Venezuela in 2002 to that in 2004?
Make the answer very short. 0.75. What is the ratio of the Value added (current US$) in Arab World in 2002 to that in 2005?
Your answer should be compact. 0.52. What is the ratio of the Value added (current US$) in Saudi Arabia in 2002 to that in 2005?
Provide a short and direct response. 0.48. What is the ratio of the Value added (current US$) in Sudan in 2002 to that in 2005?
Make the answer very short. 0.41. What is the ratio of the Value added (current US$) of Venezuela in 2002 to that in 2005?
Your answer should be compact. 0.56. What is the ratio of the Value added (current US$) of Arab World in 2002 to that in 2006?
Ensure brevity in your answer.  0.43. What is the ratio of the Value added (current US$) in Saudi Arabia in 2002 to that in 2006?
Provide a short and direct response. 0.41. What is the ratio of the Value added (current US$) in Sudan in 2002 to that in 2006?
Your answer should be compact. 0.31. What is the ratio of the Value added (current US$) in Venezuela in 2002 to that in 2006?
Your answer should be very brief. 0.45. What is the ratio of the Value added (current US$) in Arab World in 2002 to that in 2007?
Keep it short and to the point. 0.37. What is the ratio of the Value added (current US$) in Saudi Arabia in 2002 to that in 2007?
Ensure brevity in your answer.  0.37. What is the ratio of the Value added (current US$) in Sudan in 2002 to that in 2007?
Ensure brevity in your answer.  0.22. What is the ratio of the Value added (current US$) of Venezuela in 2002 to that in 2007?
Make the answer very short. 0.38. What is the ratio of the Value added (current US$) of Arab World in 2003 to that in 2004?
Keep it short and to the point. 0.81. What is the ratio of the Value added (current US$) of Saudi Arabia in 2003 to that in 2004?
Your answer should be very brief. 0.79. What is the ratio of the Value added (current US$) of Sudan in 2003 to that in 2004?
Make the answer very short. 0.73. What is the ratio of the Value added (current US$) of Venezuela in 2003 to that in 2004?
Ensure brevity in your answer.  0.71. What is the ratio of the Value added (current US$) in Arab World in 2003 to that in 2005?
Your answer should be compact. 0.6. What is the ratio of the Value added (current US$) of Saudi Arabia in 2003 to that in 2005?
Make the answer very short. 0.57. What is the ratio of the Value added (current US$) in Sudan in 2003 to that in 2005?
Ensure brevity in your answer.  0.53. What is the ratio of the Value added (current US$) in Venezuela in 2003 to that in 2005?
Your answer should be compact. 0.53. What is the ratio of the Value added (current US$) of Arab World in 2003 to that in 2006?
Your response must be concise. 0.5. What is the ratio of the Value added (current US$) in Saudi Arabia in 2003 to that in 2006?
Ensure brevity in your answer.  0.49. What is the ratio of the Value added (current US$) in Sudan in 2003 to that in 2006?
Your response must be concise. 0.4. What is the ratio of the Value added (current US$) of Venezuela in 2003 to that in 2006?
Provide a succinct answer. 0.43. What is the ratio of the Value added (current US$) in Arab World in 2003 to that in 2007?
Make the answer very short. 0.44. What is the ratio of the Value added (current US$) in Saudi Arabia in 2003 to that in 2007?
Provide a short and direct response. 0.44. What is the ratio of the Value added (current US$) of Sudan in 2003 to that in 2007?
Ensure brevity in your answer.  0.28. What is the ratio of the Value added (current US$) of Venezuela in 2003 to that in 2007?
Give a very brief answer. 0.36. What is the ratio of the Value added (current US$) of Arab World in 2004 to that in 2005?
Ensure brevity in your answer.  0.75. What is the ratio of the Value added (current US$) in Saudi Arabia in 2004 to that in 2005?
Your answer should be very brief. 0.73. What is the ratio of the Value added (current US$) of Sudan in 2004 to that in 2005?
Your response must be concise. 0.72. What is the ratio of the Value added (current US$) in Venezuela in 2004 to that in 2005?
Give a very brief answer. 0.74. What is the ratio of the Value added (current US$) in Arab World in 2004 to that in 2006?
Give a very brief answer. 0.62. What is the ratio of the Value added (current US$) of Saudi Arabia in 2004 to that in 2006?
Provide a short and direct response. 0.62. What is the ratio of the Value added (current US$) of Sudan in 2004 to that in 2006?
Keep it short and to the point. 0.55. What is the ratio of the Value added (current US$) of Venezuela in 2004 to that in 2006?
Make the answer very short. 0.6. What is the ratio of the Value added (current US$) of Arab World in 2004 to that in 2007?
Offer a terse response. 0.54. What is the ratio of the Value added (current US$) of Saudi Arabia in 2004 to that in 2007?
Give a very brief answer. 0.56. What is the ratio of the Value added (current US$) in Sudan in 2004 to that in 2007?
Your answer should be very brief. 0.39. What is the ratio of the Value added (current US$) in Venezuela in 2004 to that in 2007?
Provide a succinct answer. 0.51. What is the ratio of the Value added (current US$) in Arab World in 2005 to that in 2006?
Offer a very short reply. 0.83. What is the ratio of the Value added (current US$) in Saudi Arabia in 2005 to that in 2006?
Keep it short and to the point. 0.86. What is the ratio of the Value added (current US$) of Sudan in 2005 to that in 2006?
Provide a short and direct response. 0.76. What is the ratio of the Value added (current US$) in Venezuela in 2005 to that in 2006?
Offer a very short reply. 0.81. What is the ratio of the Value added (current US$) of Arab World in 2005 to that in 2007?
Your answer should be compact. 0.72. What is the ratio of the Value added (current US$) in Saudi Arabia in 2005 to that in 2007?
Provide a short and direct response. 0.78. What is the ratio of the Value added (current US$) in Sudan in 2005 to that in 2007?
Ensure brevity in your answer.  0.54. What is the ratio of the Value added (current US$) in Venezuela in 2005 to that in 2007?
Your response must be concise. 0.68. What is the ratio of the Value added (current US$) of Arab World in 2006 to that in 2007?
Make the answer very short. 0.87. What is the ratio of the Value added (current US$) in Saudi Arabia in 2006 to that in 2007?
Ensure brevity in your answer.  0.9. What is the ratio of the Value added (current US$) in Sudan in 2006 to that in 2007?
Your response must be concise. 0.71. What is the ratio of the Value added (current US$) in Venezuela in 2006 to that in 2007?
Ensure brevity in your answer.  0.84. What is the difference between the highest and the second highest Value added (current US$) of Arab World?
Your answer should be compact. 1.11e+11. What is the difference between the highest and the second highest Value added (current US$) in Saudi Arabia?
Ensure brevity in your answer.  2.52e+1. What is the difference between the highest and the second highest Value added (current US$) of Sudan?
Ensure brevity in your answer.  3.88e+09. What is the difference between the highest and the second highest Value added (current US$) in Venezuela?
Keep it short and to the point. 1.83e+1. What is the difference between the highest and the lowest Value added (current US$) in Arab World?
Your answer should be very brief. 5.54e+11. What is the difference between the highest and the lowest Value added (current US$) of Saudi Arabia?
Offer a terse response. 1.68e+11. What is the difference between the highest and the lowest Value added (current US$) of Sudan?
Make the answer very short. 1.09e+1. What is the difference between the highest and the lowest Value added (current US$) of Venezuela?
Make the answer very short. 7.27e+1. 